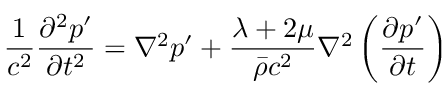<formula> <loc_0><loc_0><loc_500><loc_500>\frac { 1 } { c ^ { 2 } } \frac { \partial ^ { 2 } p ^ { \prime } } { \partial t ^ { 2 } } = \nabla ^ { 2 } p ^ { \prime } + \frac { \lambda + 2 \mu } { \bar { \rho } c ^ { 2 } } \nabla ^ { 2 } \left ( \frac { \partial p ^ { \prime } } { \partial t } \right )</formula> 